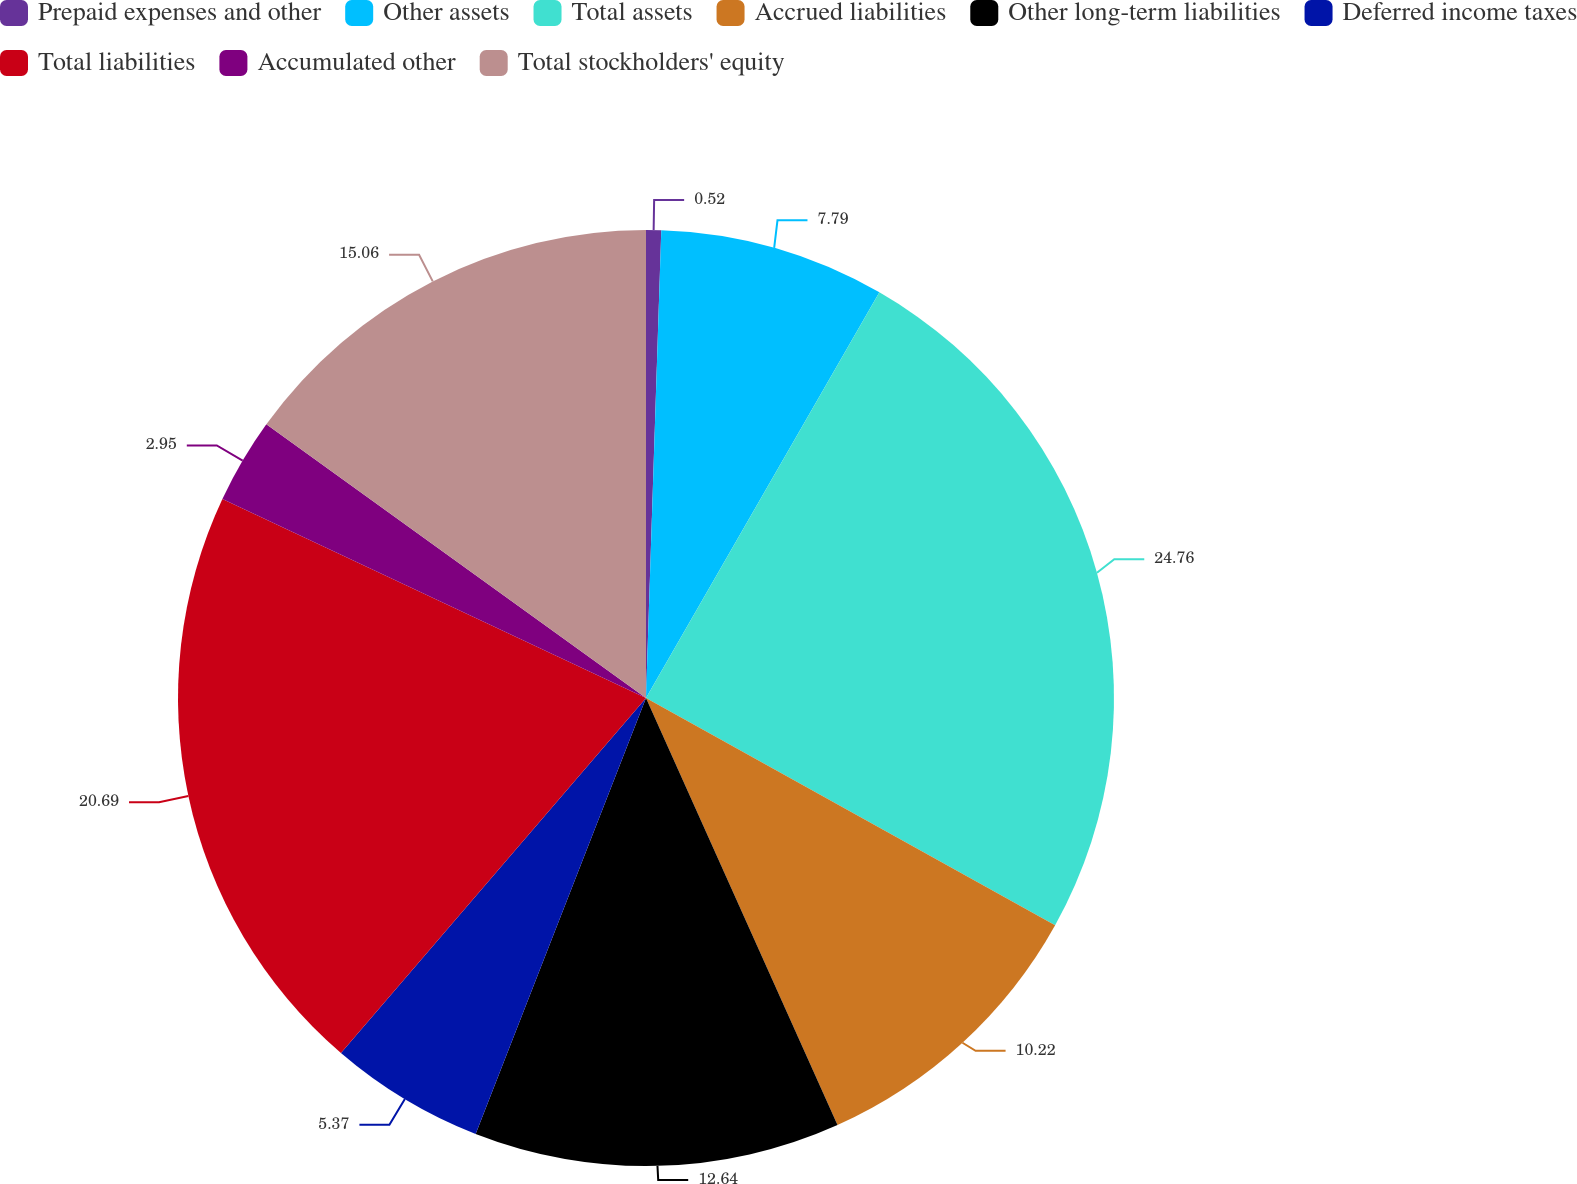<chart> <loc_0><loc_0><loc_500><loc_500><pie_chart><fcel>Prepaid expenses and other<fcel>Other assets<fcel>Total assets<fcel>Accrued liabilities<fcel>Other long-term liabilities<fcel>Deferred income taxes<fcel>Total liabilities<fcel>Accumulated other<fcel>Total stockholders' equity<nl><fcel>0.52%<fcel>7.79%<fcel>24.76%<fcel>10.22%<fcel>12.64%<fcel>5.37%<fcel>20.69%<fcel>2.95%<fcel>15.06%<nl></chart> 